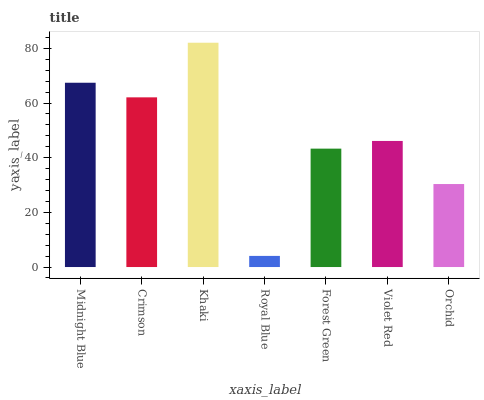Is Crimson the minimum?
Answer yes or no. No. Is Crimson the maximum?
Answer yes or no. No. Is Midnight Blue greater than Crimson?
Answer yes or no. Yes. Is Crimson less than Midnight Blue?
Answer yes or no. Yes. Is Crimson greater than Midnight Blue?
Answer yes or no. No. Is Midnight Blue less than Crimson?
Answer yes or no. No. Is Violet Red the high median?
Answer yes or no. Yes. Is Violet Red the low median?
Answer yes or no. Yes. Is Forest Green the high median?
Answer yes or no. No. Is Crimson the low median?
Answer yes or no. No. 